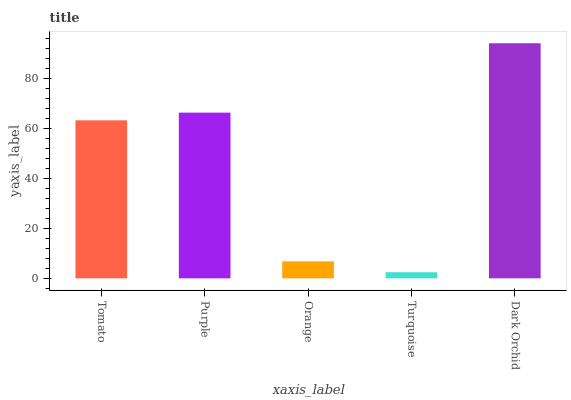Is Turquoise the minimum?
Answer yes or no. Yes. Is Dark Orchid the maximum?
Answer yes or no. Yes. Is Purple the minimum?
Answer yes or no. No. Is Purple the maximum?
Answer yes or no. No. Is Purple greater than Tomato?
Answer yes or no. Yes. Is Tomato less than Purple?
Answer yes or no. Yes. Is Tomato greater than Purple?
Answer yes or no. No. Is Purple less than Tomato?
Answer yes or no. No. Is Tomato the high median?
Answer yes or no. Yes. Is Tomato the low median?
Answer yes or no. Yes. Is Turquoise the high median?
Answer yes or no. No. Is Purple the low median?
Answer yes or no. No. 